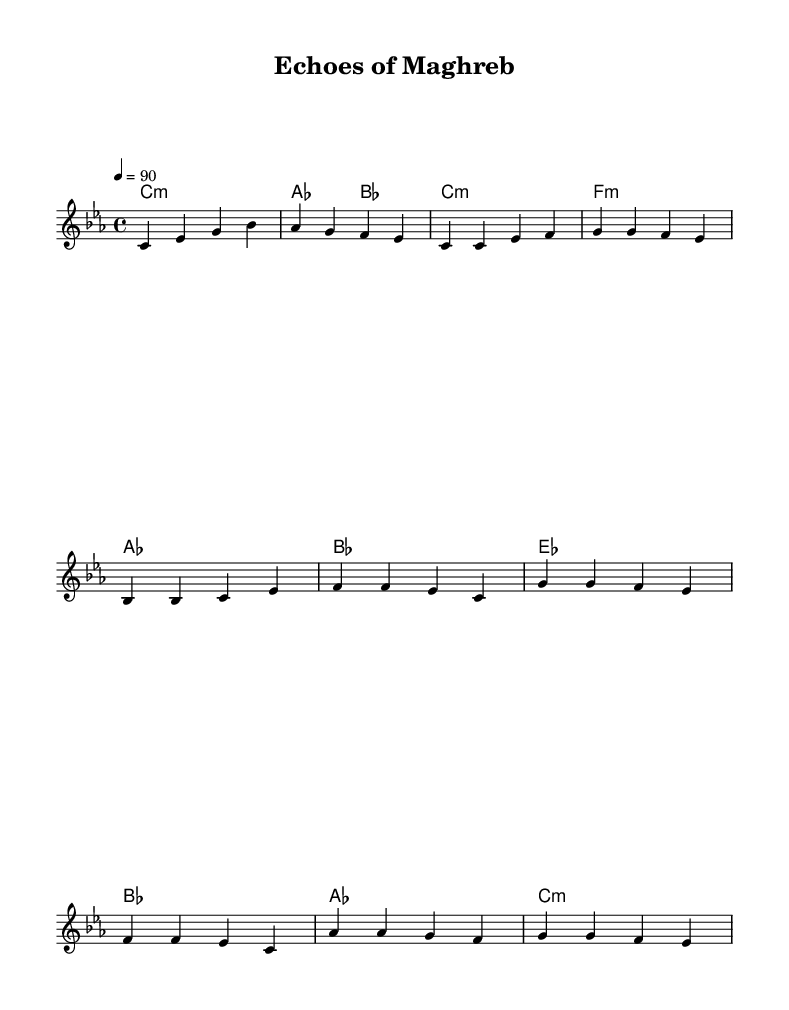What is the key signature of this music? The key signature is C minor, which has three flats (B flat, E flat, A flat).
Answer: C minor What is the time signature of this music? The time signature is 4/4, indicating four beats per measure.
Answer: 4/4 What is the tempo marking of this piece? The tempo marking indicates a speed of 90 beats per minute, specified by the notation "4 = 90".
Answer: 90 How many measures are in the chorus section? The chorus section consists of four measures, each corresponding to a line in the music.
Answer: 4 Which musical mode is primarily used in this piece? The piece is written in a minor mode, specifically C minor, which is characterized by its somber sound.
Answer: Minor What instrument is suggested for this sheet music? The score is arranged for a staff that typically accommodates melody and harmonies, implying it could be for piano or a lead instrument.
Answer: Piano What themes are likely addressed in this rap? Given the title "Echoes of Maghreb," the rap likely addresses themes relevant to North African literature, such as identity and cultural heritage.
Answer: Identity and heritage 